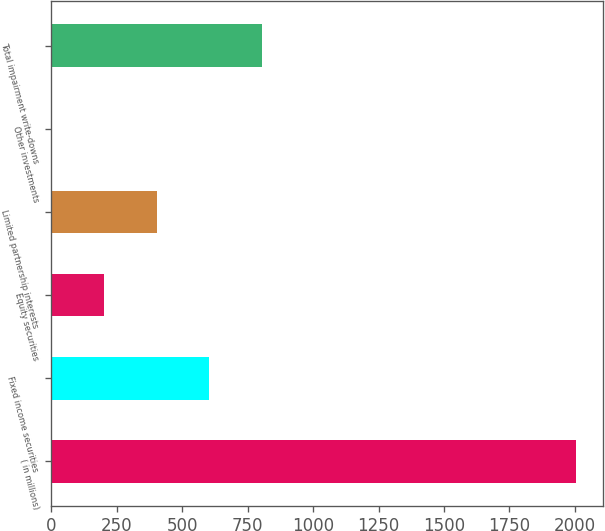Convert chart to OTSL. <chart><loc_0><loc_0><loc_500><loc_500><bar_chart><fcel>( in millions)<fcel>Fixed income securities<fcel>Equity securities<fcel>Limited partnership interests<fcel>Other investments<fcel>Total impairment write-downs<nl><fcel>2006<fcel>603.2<fcel>202.4<fcel>402.8<fcel>2<fcel>803.6<nl></chart> 